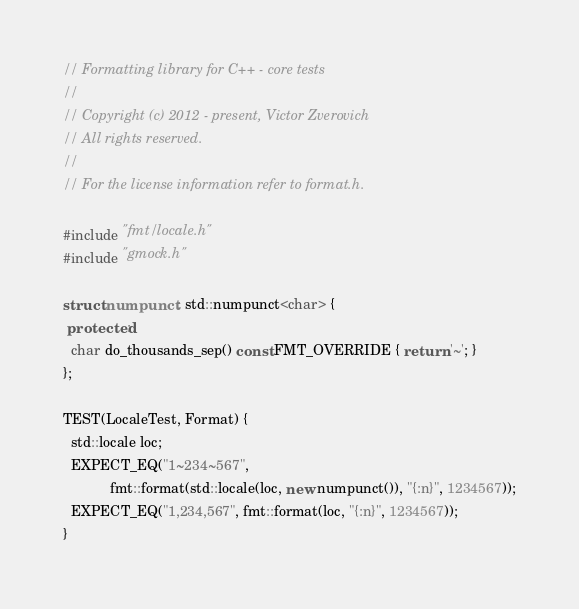<code> <loc_0><loc_0><loc_500><loc_500><_C++_>// Formatting library for C++ - core tests
//
// Copyright (c) 2012 - present, Victor Zverovich
// All rights reserved.
//
// For the license information refer to format.h.

#include "fmt/locale.h"
#include "gmock.h"

struct numpunct : std::numpunct<char> {
 protected:
  char do_thousands_sep() const FMT_OVERRIDE { return '~'; }
};

TEST(LocaleTest, Format) {
  std::locale loc;
  EXPECT_EQ("1~234~567",
            fmt::format(std::locale(loc, new numpunct()), "{:n}", 1234567));
  EXPECT_EQ("1,234,567", fmt::format(loc, "{:n}", 1234567));
}
</code> 